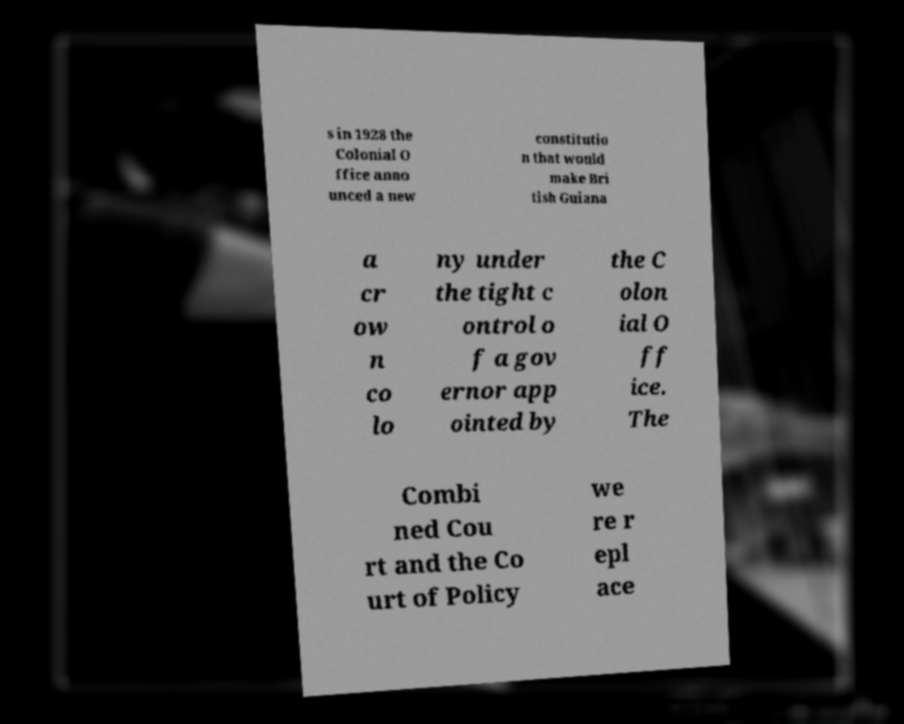For documentation purposes, I need the text within this image transcribed. Could you provide that? s in 1928 the Colonial O ffice anno unced a new constitutio n that would make Bri tish Guiana a cr ow n co lo ny under the tight c ontrol o f a gov ernor app ointed by the C olon ial O ff ice. The Combi ned Cou rt and the Co urt of Policy we re r epl ace 